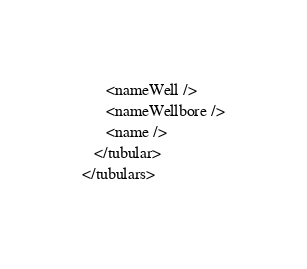<code> <loc_0><loc_0><loc_500><loc_500><_XML_>      <nameWell />
      <nameWellbore />
      <name />
   </tubular>
</tubulars>
</code> 